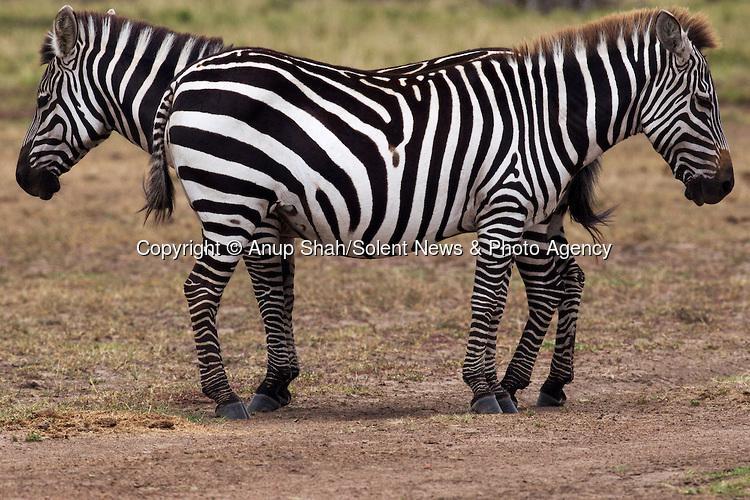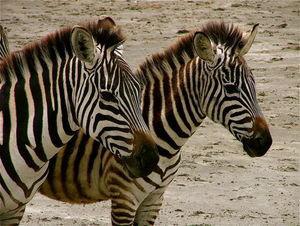The first image is the image on the left, the second image is the image on the right. Assess this claim about the two images: "Each image has two zebras and in only one of the images are they looking in the same direction.". Correct or not? Answer yes or no. Yes. The first image is the image on the left, the second image is the image on the right. Analyze the images presented: Is the assertion "In the left image two zebras are facing in opposite directions." valid? Answer yes or no. Yes. 